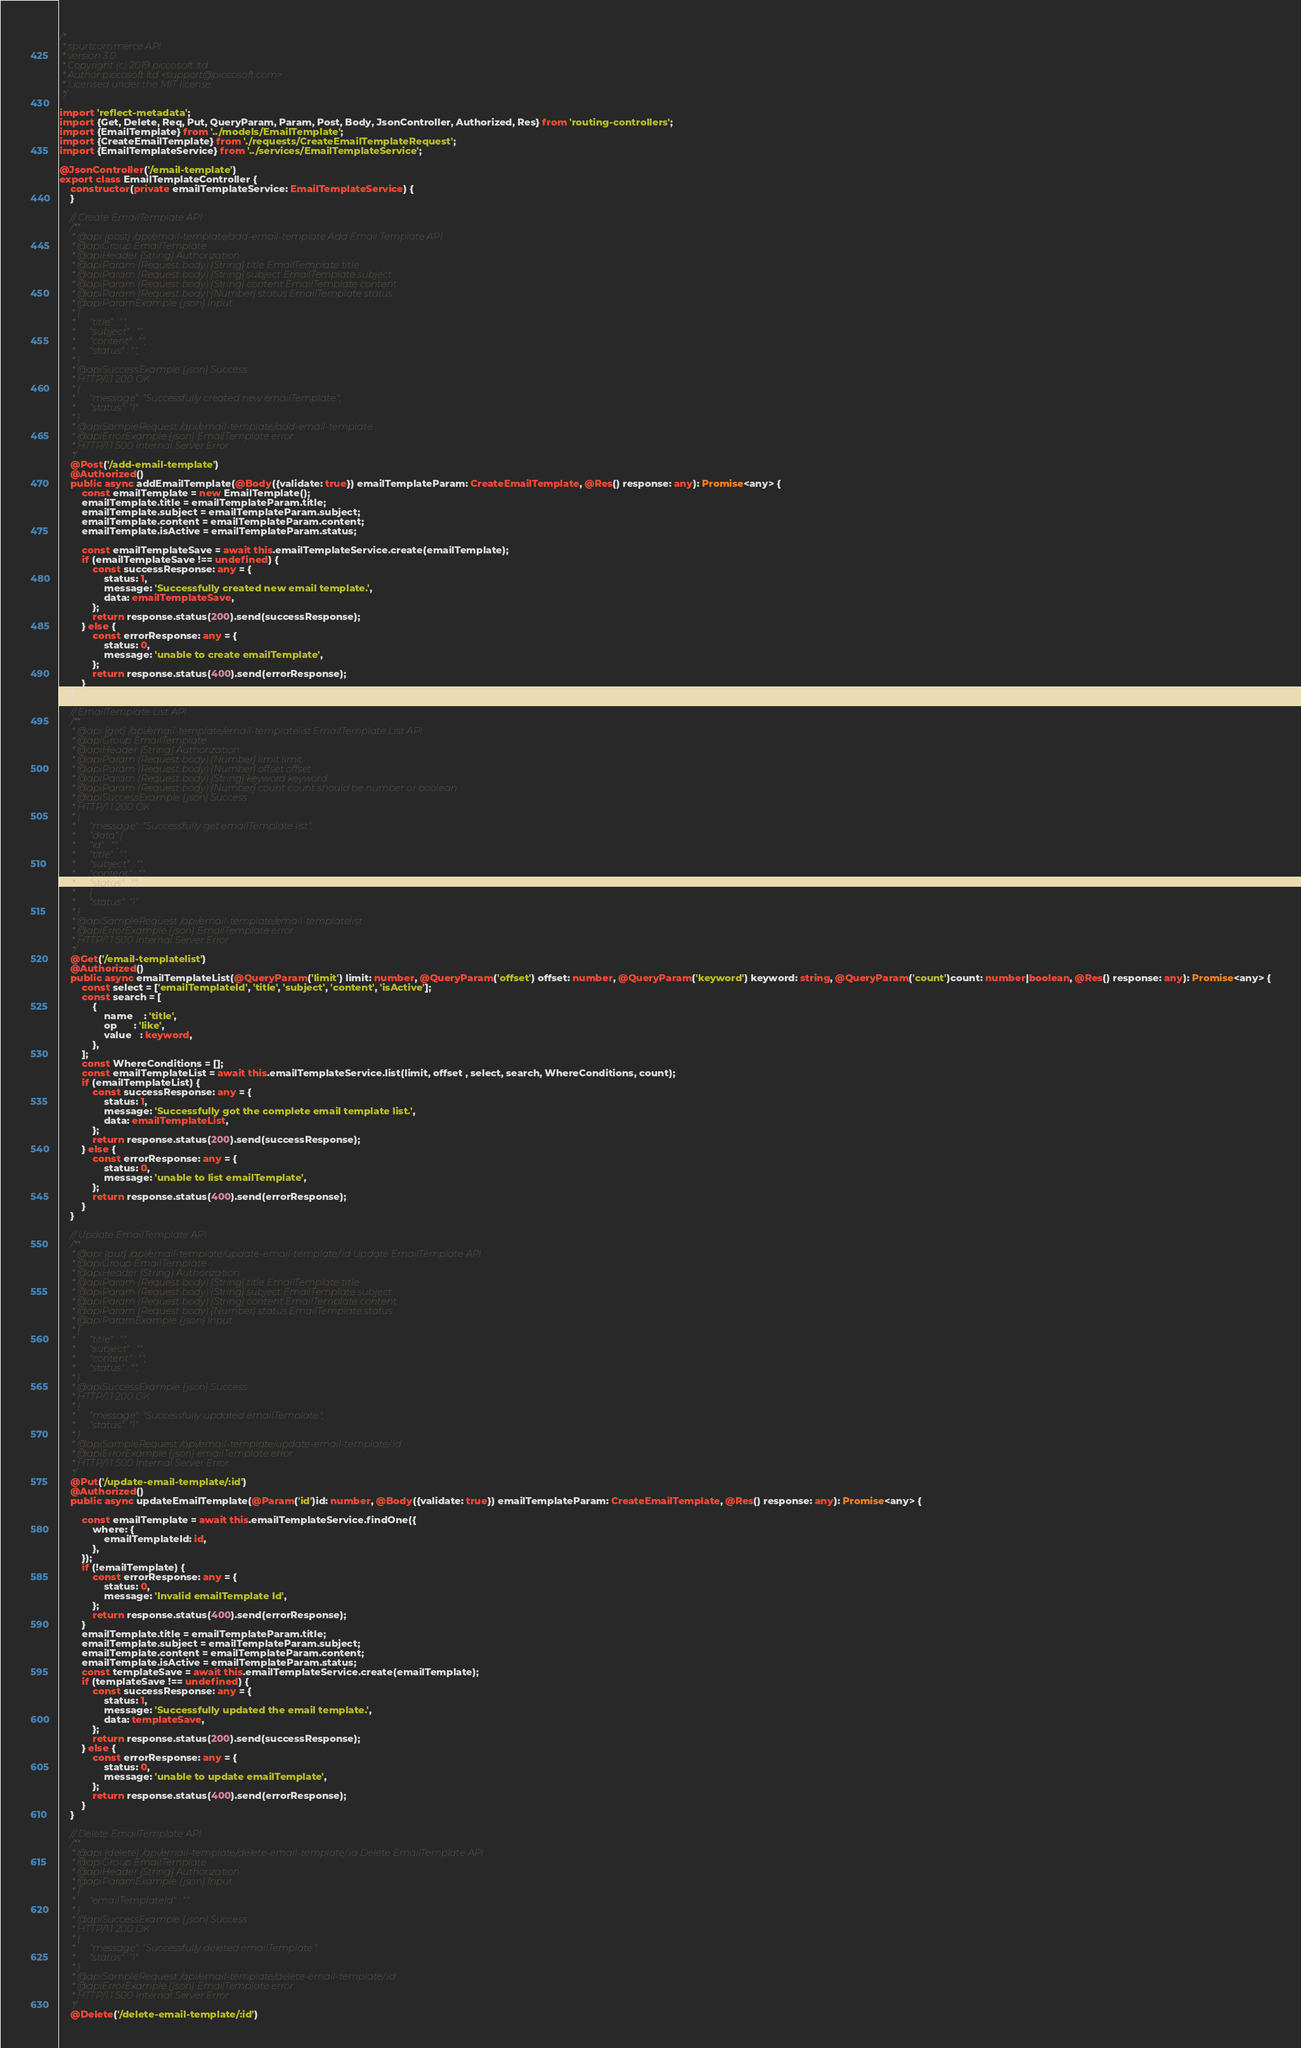Convert code to text. <code><loc_0><loc_0><loc_500><loc_500><_TypeScript_>/*
 * spurtcommerce API
 * version 3.0
 * Copyright (c) 2019 piccosoft ltd
 * Author piccosoft ltd <support@piccosoft.com>
 * Licensed under the MIT license.
 */

import 'reflect-metadata';
import {Get, Delete, Req, Put, QueryParam, Param, Post, Body, JsonController, Authorized, Res} from 'routing-controllers';
import {EmailTemplate} from '../models/EmailTemplate';
import {CreateEmailTemplate} from './requests/CreateEmailTemplateRequest';
import {EmailTemplateService} from '../services/EmailTemplateService';

@JsonController('/email-template')
export class EmailTemplateController {
    constructor(private emailTemplateService: EmailTemplateService) {
    }

    // Create EmailTemplate API
    /**
     * @api {post} /api/email-template/add-email-template Add Email Template API
     * @apiGroup EmailTemplate
     * @apiHeader {String} Authorization
     * @apiParam (Request body) {String} title EmailTemplate title
     * @apiParam (Request body) {String} subject EmailTemplate subject
     * @apiParam (Request body) {String} content EmailTemplate content
     * @apiParam (Request body) {Number} status EmailTemplate status
     * @apiParamExample {json} Input
     * {
     *      "title" : "",
     *      "subject" : "",
     *      "content" : "",
     *      "status" : "",
     * }
     * @apiSuccessExample {json} Success
     * HTTP/1.1 200 OK
     * {
     *      "message": "Successfully created new emailTemplate.",
     *      "status": "1"
     * }
     * @apiSampleRequest /api/email-template/add-email-template
     * @apiErrorExample {json} EmailTemplate error
     * HTTP/1.1 500 Internal Server Error
     */
    @Post('/add-email-template')
    @Authorized()
    public async addEmailTemplate(@Body({validate: true}) emailTemplateParam: CreateEmailTemplate, @Res() response: any): Promise<any> {
        const emailTemplate = new EmailTemplate();
        emailTemplate.title = emailTemplateParam.title;
        emailTemplate.subject = emailTemplateParam.subject;
        emailTemplate.content = emailTemplateParam.content;
        emailTemplate.isActive = emailTemplateParam.status;

        const emailTemplateSave = await this.emailTemplateService.create(emailTemplate);
        if (emailTemplateSave !== undefined) {
            const successResponse: any = {
                status: 1,
                message: 'Successfully created new email template.',
                data: emailTemplateSave,
            };
            return response.status(200).send(successResponse);
        } else {
            const errorResponse: any = {
                status: 0,
                message: 'unable to create emailTemplate',
            };
            return response.status(400).send(errorResponse);
        }
    }

    // EmailTemplate List API
    /**
     * @api {get} /api/email-template/email-templatelist EmailTemplate List API
     * @apiGroup EmailTemplate
     * @apiHeader {String} Authorization
     * @apiParam (Request body) {Number} limit limit
     * @apiParam (Request body) {Number} offset offset
     * @apiParam (Request body) {String} keyword keyword
     * @apiParam (Request body) {Number} count count should be number or boolean
     * @apiSuccessExample {json} Success
     * HTTP/1.1 200 OK
     * {
     *      "message": "Successfully get emailTemplate list",
     *      "data":{
     *      "id" : "",
     *      "title" : "",
     *      "subject" : "",
     *      "content" : "",
     *      "status" : "",
     *      }
     *      "status": "1"
     * }
     * @apiSampleRequest /api/email-template/email-templatelist
     * @apiErrorExample {json} EmailTemplate error
     * HTTP/1.1 500 Internal Server Error
     */
    @Get('/email-templatelist')
    @Authorized()
    public async emailTemplateList(@QueryParam('limit') limit: number, @QueryParam('offset') offset: number, @QueryParam('keyword') keyword: string, @QueryParam('count')count: number|boolean, @Res() response: any): Promise<any> {
        const select = ['emailTemplateId', 'title', 'subject', 'content', 'isActive'];
        const search = [
            {
                name    : 'title',
                op      : 'like',
                value   : keyword,
            },
        ];
        const WhereConditions = [];
        const emailTemplateList = await this.emailTemplateService.list(limit, offset , select, search, WhereConditions, count);
        if (emailTemplateList) {
            const successResponse: any = {
                status: 1,
                message: 'Successfully got the complete email template list.',
                data: emailTemplateList,
            };
            return response.status(200).send(successResponse);
        } else {
            const errorResponse: any = {
                status: 0,
                message: 'unable to list emailTemplate',
            };
            return response.status(400).send(errorResponse);
        }
    }

    // Update EmailTemplate API
    /**
     * @api {put} /api/email-template/update-email-template/:id Update EmailTemplate API
     * @apiGroup EmailTemplate
     * @apiHeader {String} Authorization
     * @apiParam (Request body) {String} title EmailTemplate title
     * @apiParam (Request body) {String} subject EmailTemplate subject
     * @apiParam (Request body) {String} content EmailTemplate content
     * @apiParam (Request body) {Number} status EmailTemplate status
     * @apiParamExample {json} Input
     * {
     *      "title" : "",
     *      "subject" : "",
     *      "content" : "",
     *      "status" : "",
     * }
     * @apiSuccessExample {json} Success
     * HTTP/1.1 200 OK
     * {
     *      "message": "Successfully updated emailTemplate.",
     *      "status": "1"
     * }
     * @apiSampleRequest /api/email-template/update-email-template/:id
     * @apiErrorExample {json} emailTemplate error
     * HTTP/1.1 500 Internal Server Error
     */
    @Put('/update-email-template/:id')
    @Authorized()
    public async updateEmailTemplate(@Param('id')id: number, @Body({validate: true}) emailTemplateParam: CreateEmailTemplate, @Res() response: any): Promise<any> {

        const emailTemplate = await this.emailTemplateService.findOne({
            where: {
                emailTemplateId: id,
            },
        });
        if (!emailTemplate) {
            const errorResponse: any = {
                status: 0,
                message: 'Invalid emailTemplate Id',
            };
            return response.status(400).send(errorResponse);
        }
        emailTemplate.title = emailTemplateParam.title;
        emailTemplate.subject = emailTemplateParam.subject;
        emailTemplate.content = emailTemplateParam.content;
        emailTemplate.isActive = emailTemplateParam.status;
        const templateSave = await this.emailTemplateService.create(emailTemplate);
        if (templateSave !== undefined) {
            const successResponse: any = {
                status: 1,
                message: 'Successfully updated the email template.',
                data: templateSave,
            };
            return response.status(200).send(successResponse);
        } else {
            const errorResponse: any = {
                status: 0,
                message: 'unable to update emailTemplate',
            };
            return response.status(400).send(errorResponse);
        }
    }

    // Delete EmailTemplate API
    /**
     * @api {delete} /api/email-template/delete-email-template/:id Delete EmailTemplate API
     * @apiGroup EmailTemplate
     * @apiHeader {String} Authorization
     * @apiParamExample {json} Input
     * {
     *      "emailTemplateId" : "",
     * }
     * @apiSuccessExample {json} Success
     * HTTP/1.1 200 OK
     * {
     *      "message": "Successfully deleted emailTemplate.",
     *      "status": "1"
     * }
     * @apiSampleRequest /api/email-template/delete-email-template/:id
     * @apiErrorExample {json} EmailTemplate error
     * HTTP/1.1 500 Internal Server Error
     */
    @Delete('/delete-email-template/:id')</code> 